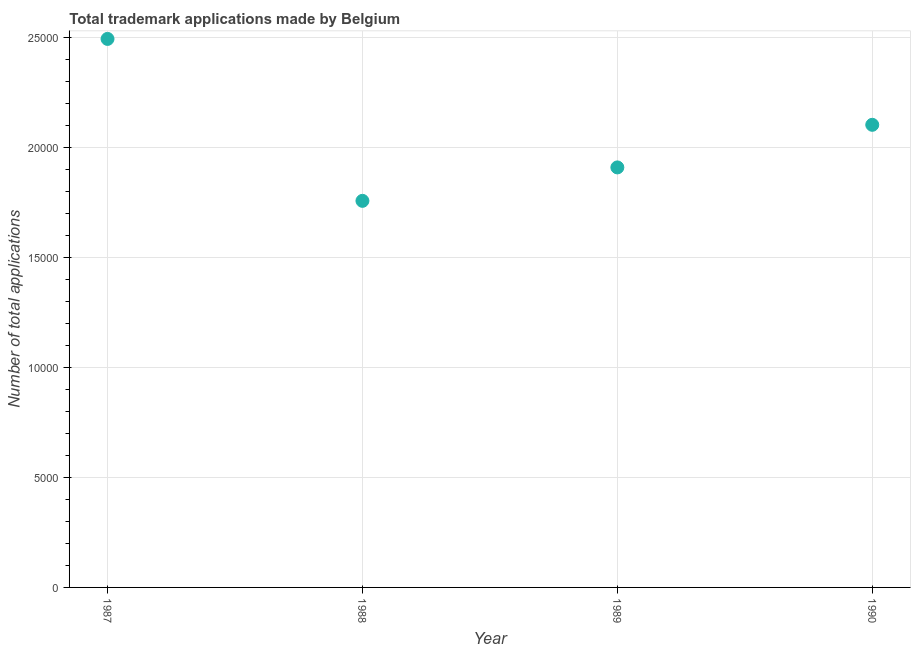What is the number of trademark applications in 1987?
Your response must be concise. 2.50e+04. Across all years, what is the maximum number of trademark applications?
Keep it short and to the point. 2.50e+04. Across all years, what is the minimum number of trademark applications?
Offer a very short reply. 1.76e+04. In which year was the number of trademark applications minimum?
Make the answer very short. 1988. What is the sum of the number of trademark applications?
Your answer should be compact. 8.27e+04. What is the difference between the number of trademark applications in 1988 and 1990?
Your response must be concise. -3459. What is the average number of trademark applications per year?
Provide a succinct answer. 2.07e+04. What is the median number of trademark applications?
Offer a terse response. 2.01e+04. Do a majority of the years between 1987 and 1989 (inclusive) have number of trademark applications greater than 1000 ?
Your answer should be compact. Yes. What is the ratio of the number of trademark applications in 1987 to that in 1989?
Make the answer very short. 1.31. Is the number of trademark applications in 1987 less than that in 1988?
Give a very brief answer. No. Is the difference between the number of trademark applications in 1987 and 1990 greater than the difference between any two years?
Offer a very short reply. No. What is the difference between the highest and the second highest number of trademark applications?
Make the answer very short. 3907. Is the sum of the number of trademark applications in 1988 and 1989 greater than the maximum number of trademark applications across all years?
Give a very brief answer. Yes. What is the difference between the highest and the lowest number of trademark applications?
Your response must be concise. 7366. In how many years, is the number of trademark applications greater than the average number of trademark applications taken over all years?
Ensure brevity in your answer.  2. How many years are there in the graph?
Your answer should be very brief. 4. What is the difference between two consecutive major ticks on the Y-axis?
Your response must be concise. 5000. Are the values on the major ticks of Y-axis written in scientific E-notation?
Your answer should be compact. No. Does the graph contain grids?
Keep it short and to the point. Yes. What is the title of the graph?
Offer a very short reply. Total trademark applications made by Belgium. What is the label or title of the X-axis?
Your answer should be very brief. Year. What is the label or title of the Y-axis?
Your answer should be very brief. Number of total applications. What is the Number of total applications in 1987?
Offer a terse response. 2.50e+04. What is the Number of total applications in 1988?
Your response must be concise. 1.76e+04. What is the Number of total applications in 1989?
Ensure brevity in your answer.  1.91e+04. What is the Number of total applications in 1990?
Ensure brevity in your answer.  2.10e+04. What is the difference between the Number of total applications in 1987 and 1988?
Give a very brief answer. 7366. What is the difference between the Number of total applications in 1987 and 1989?
Offer a terse response. 5845. What is the difference between the Number of total applications in 1987 and 1990?
Your answer should be very brief. 3907. What is the difference between the Number of total applications in 1988 and 1989?
Offer a very short reply. -1521. What is the difference between the Number of total applications in 1988 and 1990?
Offer a terse response. -3459. What is the difference between the Number of total applications in 1989 and 1990?
Ensure brevity in your answer.  -1938. What is the ratio of the Number of total applications in 1987 to that in 1988?
Make the answer very short. 1.42. What is the ratio of the Number of total applications in 1987 to that in 1989?
Your response must be concise. 1.31. What is the ratio of the Number of total applications in 1987 to that in 1990?
Offer a terse response. 1.19. What is the ratio of the Number of total applications in 1988 to that in 1989?
Keep it short and to the point. 0.92. What is the ratio of the Number of total applications in 1988 to that in 1990?
Your answer should be compact. 0.84. What is the ratio of the Number of total applications in 1989 to that in 1990?
Give a very brief answer. 0.91. 